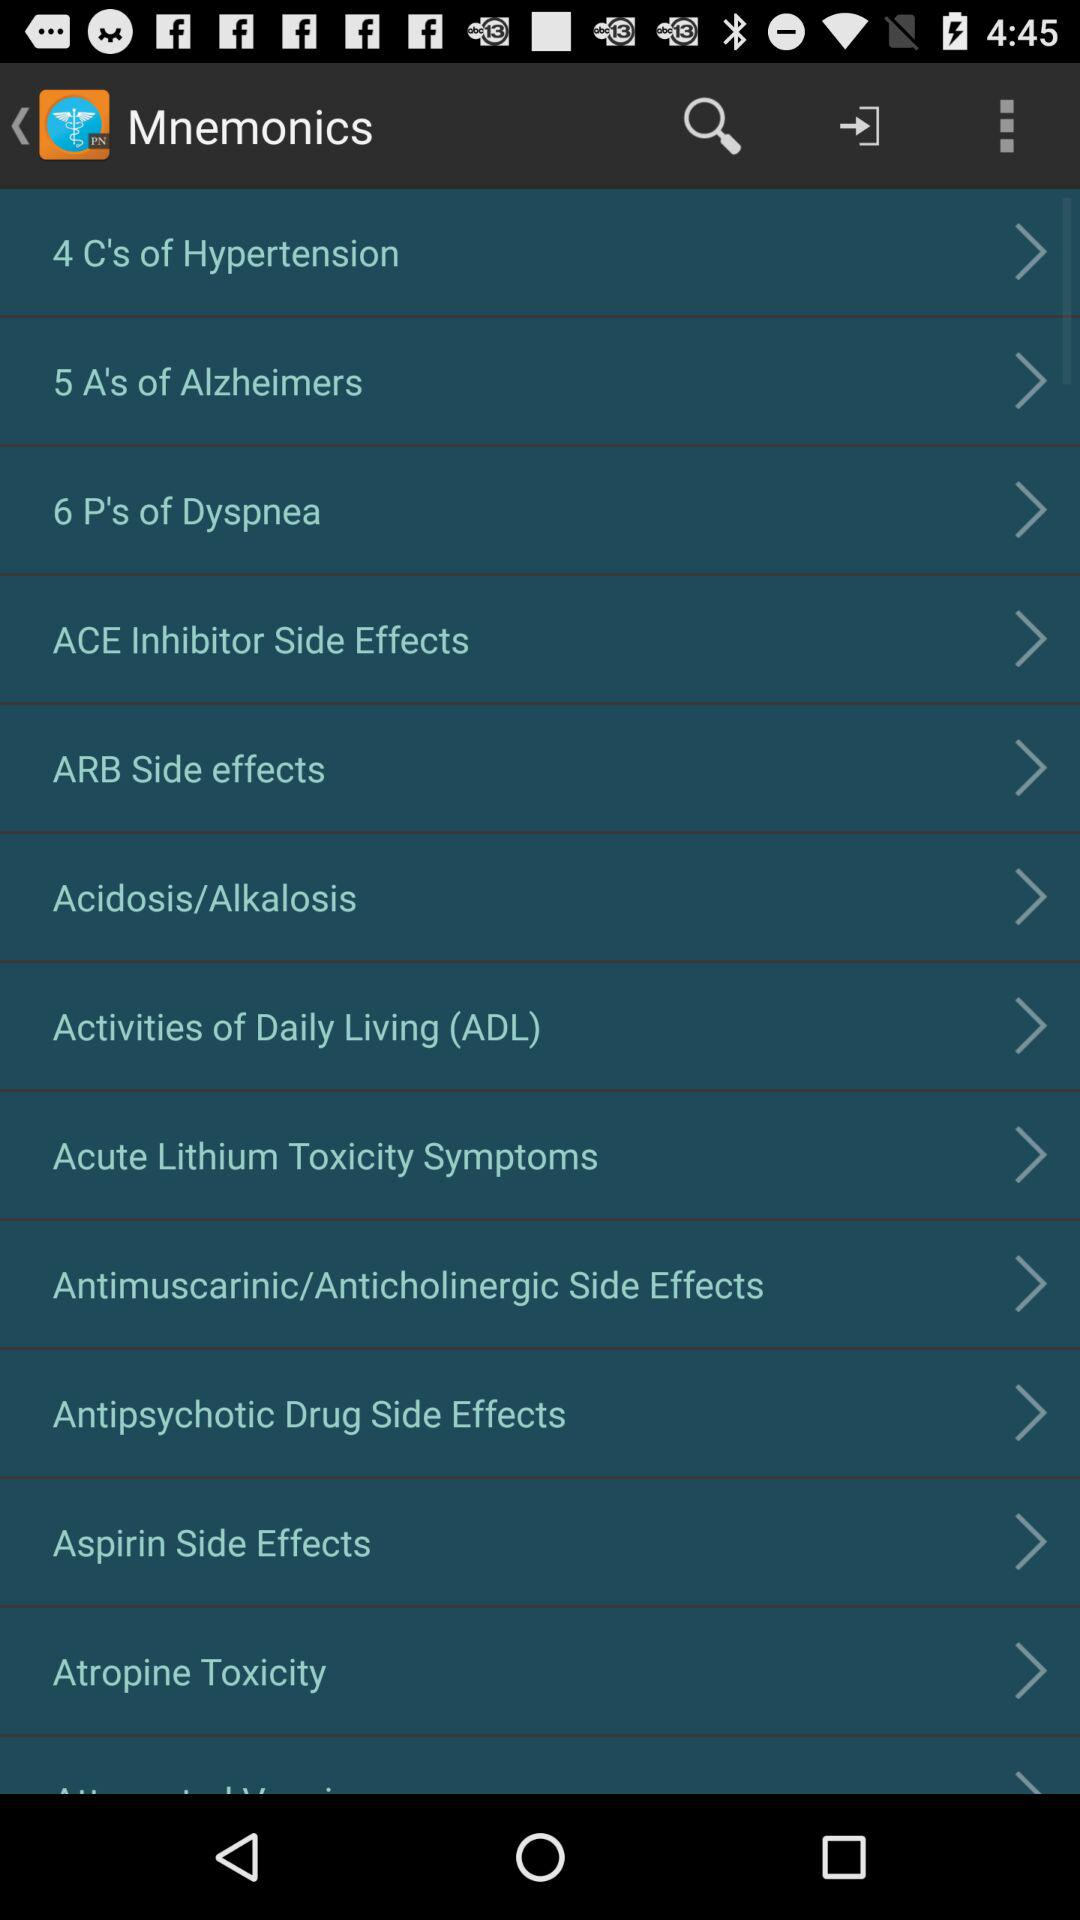What is the application name? The application name is "Mnemonics". 